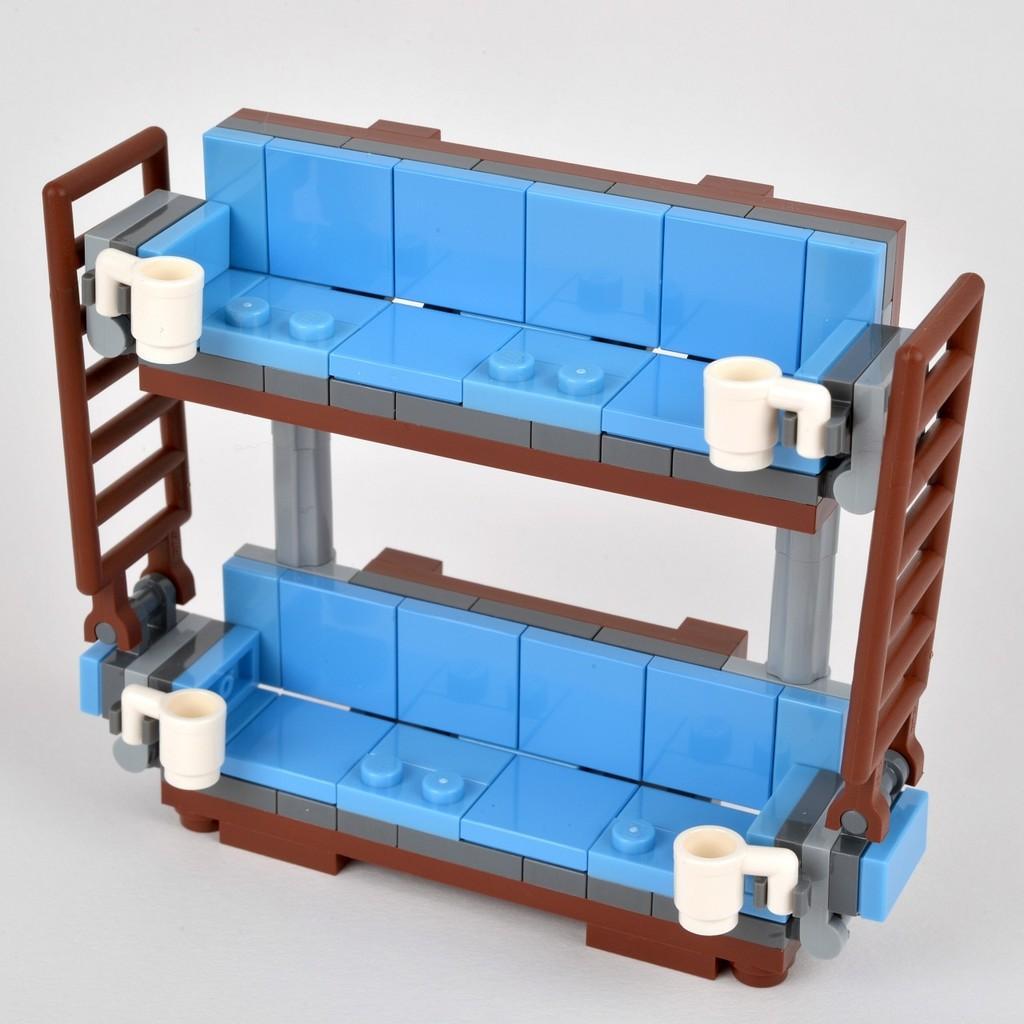How would you summarize this image in a sentence or two? In the center of this picture we can see a Lego and we can see a rack and some white color objects and we can see some other objects. 